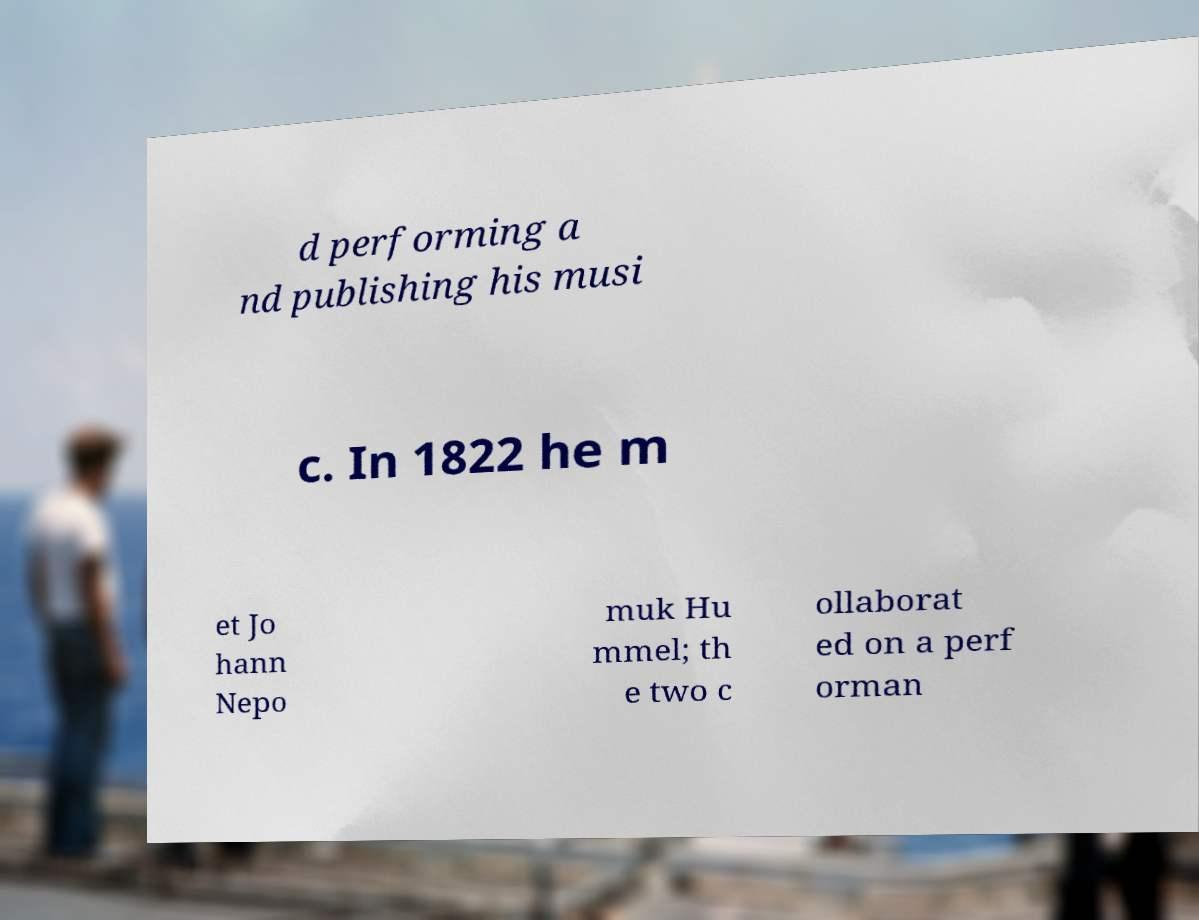Could you extract and type out the text from this image? d performing a nd publishing his musi c. In 1822 he m et Jo hann Nepo muk Hu mmel; th e two c ollaborat ed on a perf orman 